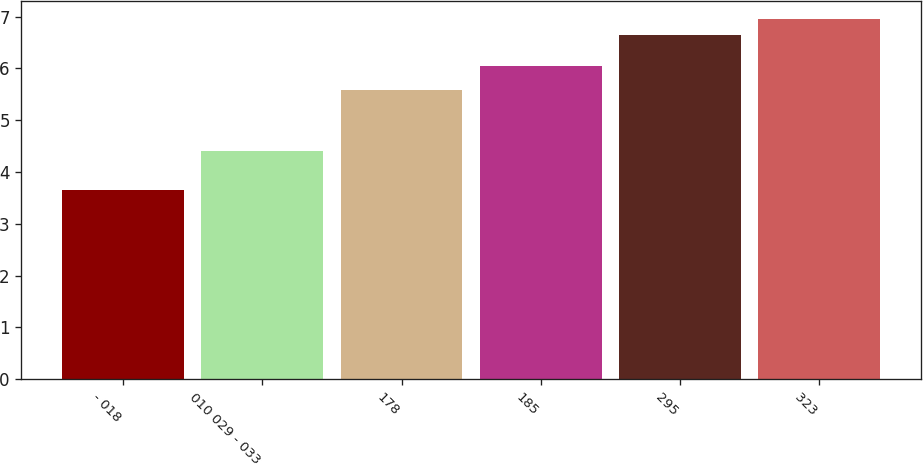Convert chart. <chart><loc_0><loc_0><loc_500><loc_500><bar_chart><fcel>- 018<fcel>010 029 - 033<fcel>178<fcel>185<fcel>295<fcel>323<nl><fcel>3.66<fcel>4.4<fcel>5.59<fcel>6.04<fcel>6.64<fcel>6.96<nl></chart> 